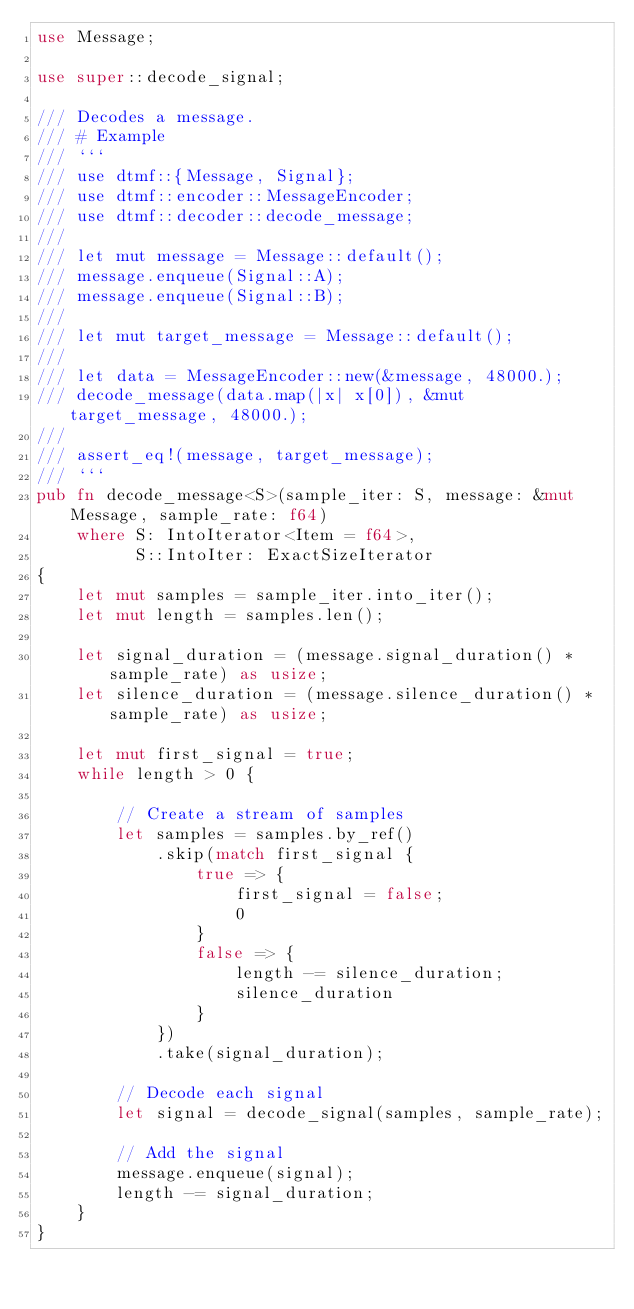<code> <loc_0><loc_0><loc_500><loc_500><_Rust_>use Message;

use super::decode_signal;

/// Decodes a message.
/// # Example
/// ```
/// use dtmf::{Message, Signal};
/// use dtmf::encoder::MessageEncoder;
/// use dtmf::decoder::decode_message;
///
/// let mut message = Message::default();
/// message.enqueue(Signal::A);
/// message.enqueue(Signal::B);
///
/// let mut target_message = Message::default();
///
/// let data = MessageEncoder::new(&message, 48000.);
/// decode_message(data.map(|x| x[0]), &mut target_message, 48000.);
///
/// assert_eq!(message, target_message);
/// ```
pub fn decode_message<S>(sample_iter: S, message: &mut Message, sample_rate: f64)
    where S: IntoIterator<Item = f64>,
          S::IntoIter: ExactSizeIterator
{
    let mut samples = sample_iter.into_iter();
    let mut length = samples.len();

    let signal_duration = (message.signal_duration() * sample_rate) as usize;
    let silence_duration = (message.silence_duration() * sample_rate) as usize;

    let mut first_signal = true;
    while length > 0 {

        // Create a stream of samples
        let samples = samples.by_ref()
            .skip(match first_signal {
                true => {
                    first_signal = false;
                    0
                }
                false => {
                    length -= silence_duration;
                    silence_duration
                }
            })
            .take(signal_duration);

        // Decode each signal
        let signal = decode_signal(samples, sample_rate);

        // Add the signal
        message.enqueue(signal);
        length -= signal_duration;
    }
}
</code> 